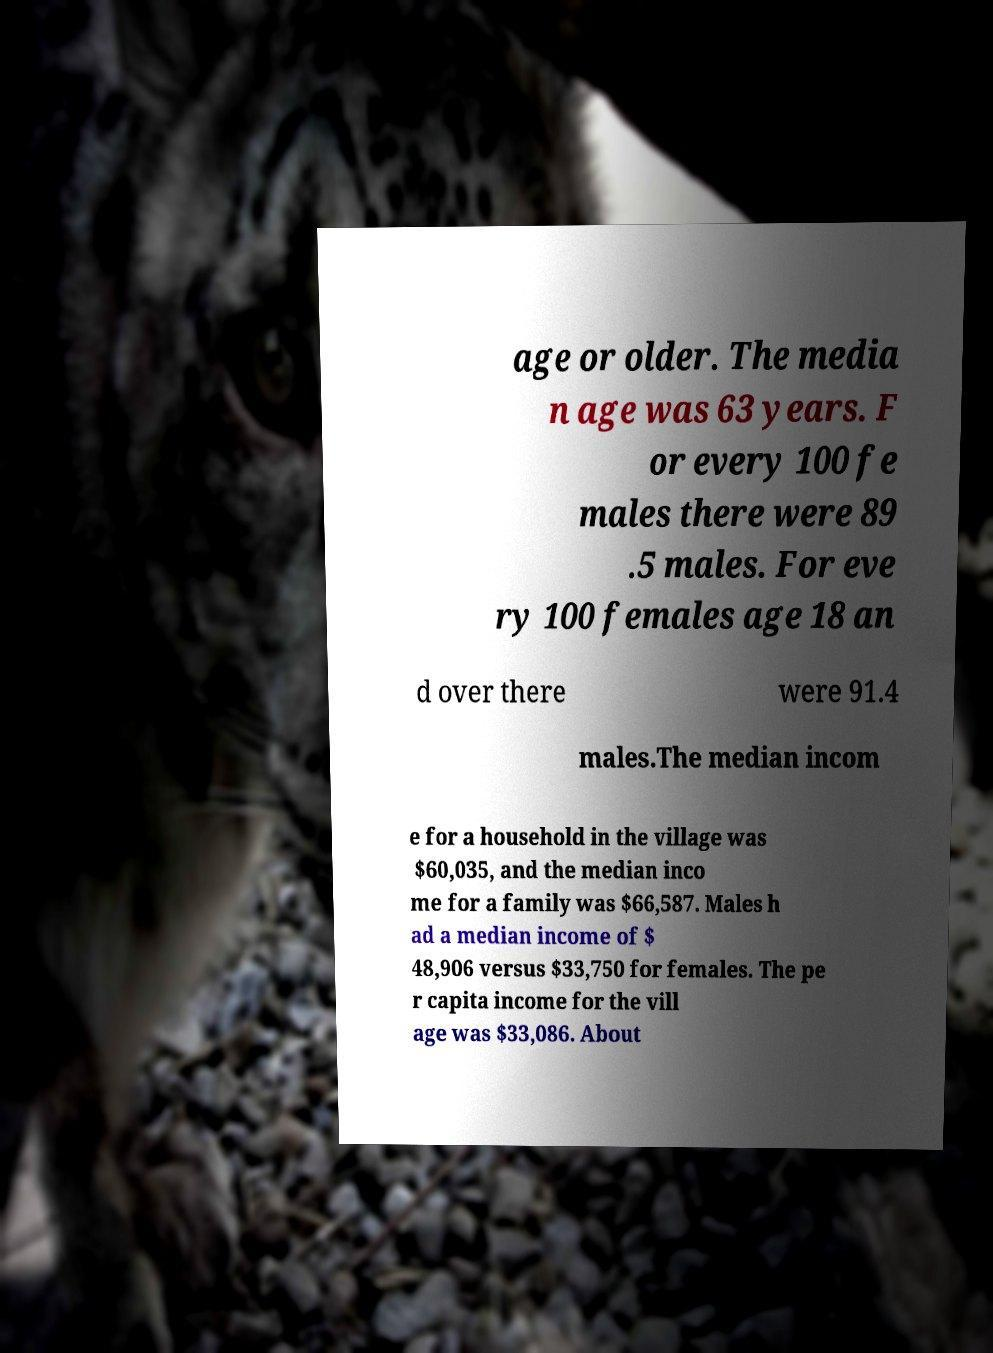Please identify and transcribe the text found in this image. age or older. The media n age was 63 years. F or every 100 fe males there were 89 .5 males. For eve ry 100 females age 18 an d over there were 91.4 males.The median incom e for a household in the village was $60,035, and the median inco me for a family was $66,587. Males h ad a median income of $ 48,906 versus $33,750 for females. The pe r capita income for the vill age was $33,086. About 